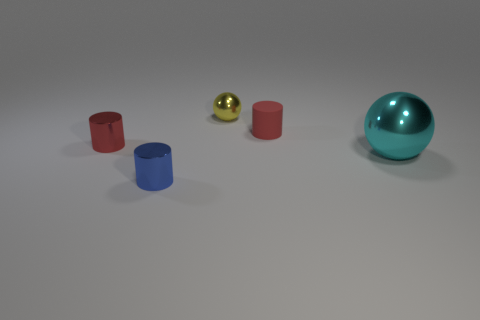Subtract all small red metal cylinders. How many cylinders are left? 2 Subtract all blue cylinders. How many cylinders are left? 2 Subtract all balls. How many objects are left? 3 Subtract all gray cylinders. Subtract all blue balls. How many cylinders are left? 3 Subtract all yellow balls. How many purple cylinders are left? 0 Subtract all metallic objects. Subtract all rubber things. How many objects are left? 0 Add 3 tiny metallic cylinders. How many tiny metallic cylinders are left? 5 Add 2 purple shiny blocks. How many purple shiny blocks exist? 2 Add 3 yellow metal balls. How many objects exist? 8 Subtract 0 green balls. How many objects are left? 5 